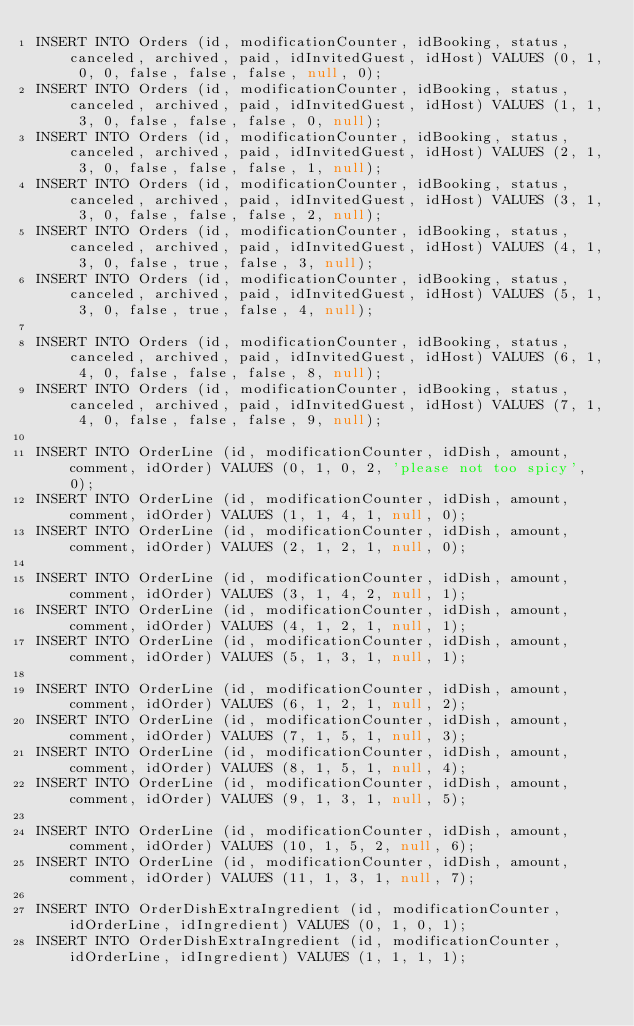<code> <loc_0><loc_0><loc_500><loc_500><_SQL_>INSERT INTO Orders (id, modificationCounter, idBooking, status, canceled, archived, paid, idInvitedGuest, idHost) VALUES (0, 1, 0, 0, false, false, false, null, 0);
INSERT INTO Orders (id, modificationCounter, idBooking, status, canceled, archived, paid, idInvitedGuest, idHost) VALUES (1, 1, 3, 0, false, false, false, 0, null);
INSERT INTO Orders (id, modificationCounter, idBooking, status, canceled, archived, paid, idInvitedGuest, idHost) VALUES (2, 1, 3, 0, false, false, false, 1, null);
INSERT INTO Orders (id, modificationCounter, idBooking, status, canceled, archived, paid, idInvitedGuest, idHost) VALUES (3, 1, 3, 0, false, false, false, 2, null);
INSERT INTO Orders (id, modificationCounter, idBooking, status, canceled, archived, paid, idInvitedGuest, idHost) VALUES (4, 1, 3, 0, false, true, false, 3, null);
INSERT INTO Orders (id, modificationCounter, idBooking, status, canceled, archived, paid, idInvitedGuest, idHost) VALUES (5, 1, 3, 0, false, true, false, 4, null);

INSERT INTO Orders (id, modificationCounter, idBooking, status, canceled, archived, paid, idInvitedGuest, idHost) VALUES (6, 1, 4, 0, false, false, false, 8, null);
INSERT INTO Orders (id, modificationCounter, idBooking, status, canceled, archived, paid, idInvitedGuest, idHost) VALUES (7, 1, 4, 0, false, false, false, 9, null);

INSERT INTO OrderLine (id, modificationCounter, idDish, amount, comment, idOrder) VALUES (0, 1, 0, 2, 'please not too spicy', 0);
INSERT INTO OrderLine (id, modificationCounter, idDish, amount, comment, idOrder) VALUES (1, 1, 4, 1, null, 0);
INSERT INTO OrderLine (id, modificationCounter, idDish, amount, comment, idOrder) VALUES (2, 1, 2, 1, null, 0);

INSERT INTO OrderLine (id, modificationCounter, idDish, amount, comment, idOrder) VALUES (3, 1, 4, 2, null, 1);
INSERT INTO OrderLine (id, modificationCounter, idDish, amount, comment, idOrder) VALUES (4, 1, 2, 1, null, 1);
INSERT INTO OrderLine (id, modificationCounter, idDish, amount, comment, idOrder) VALUES (5, 1, 3, 1, null, 1);

INSERT INTO OrderLine (id, modificationCounter, idDish, amount, comment, idOrder) VALUES (6, 1, 2, 1, null, 2);
INSERT INTO OrderLine (id, modificationCounter, idDish, amount, comment, idOrder) VALUES (7, 1, 5, 1, null, 3);
INSERT INTO OrderLine (id, modificationCounter, idDish, amount, comment, idOrder) VALUES (8, 1, 5, 1, null, 4);
INSERT INTO OrderLine (id, modificationCounter, idDish, amount, comment, idOrder) VALUES (9, 1, 3, 1, null, 5);

INSERT INTO OrderLine (id, modificationCounter, idDish, amount, comment, idOrder) VALUES (10, 1, 5, 2, null, 6);
INSERT INTO OrderLine (id, modificationCounter, idDish, amount, comment, idOrder) VALUES (11, 1, 3, 1, null, 7);

INSERT INTO OrderDishExtraIngredient (id, modificationCounter, idOrderLine, idIngredient) VALUES (0, 1, 0, 1);
INSERT INTO OrderDishExtraIngredient (id, modificationCounter, idOrderLine, idIngredient) VALUES (1, 1, 1, 1);</code> 